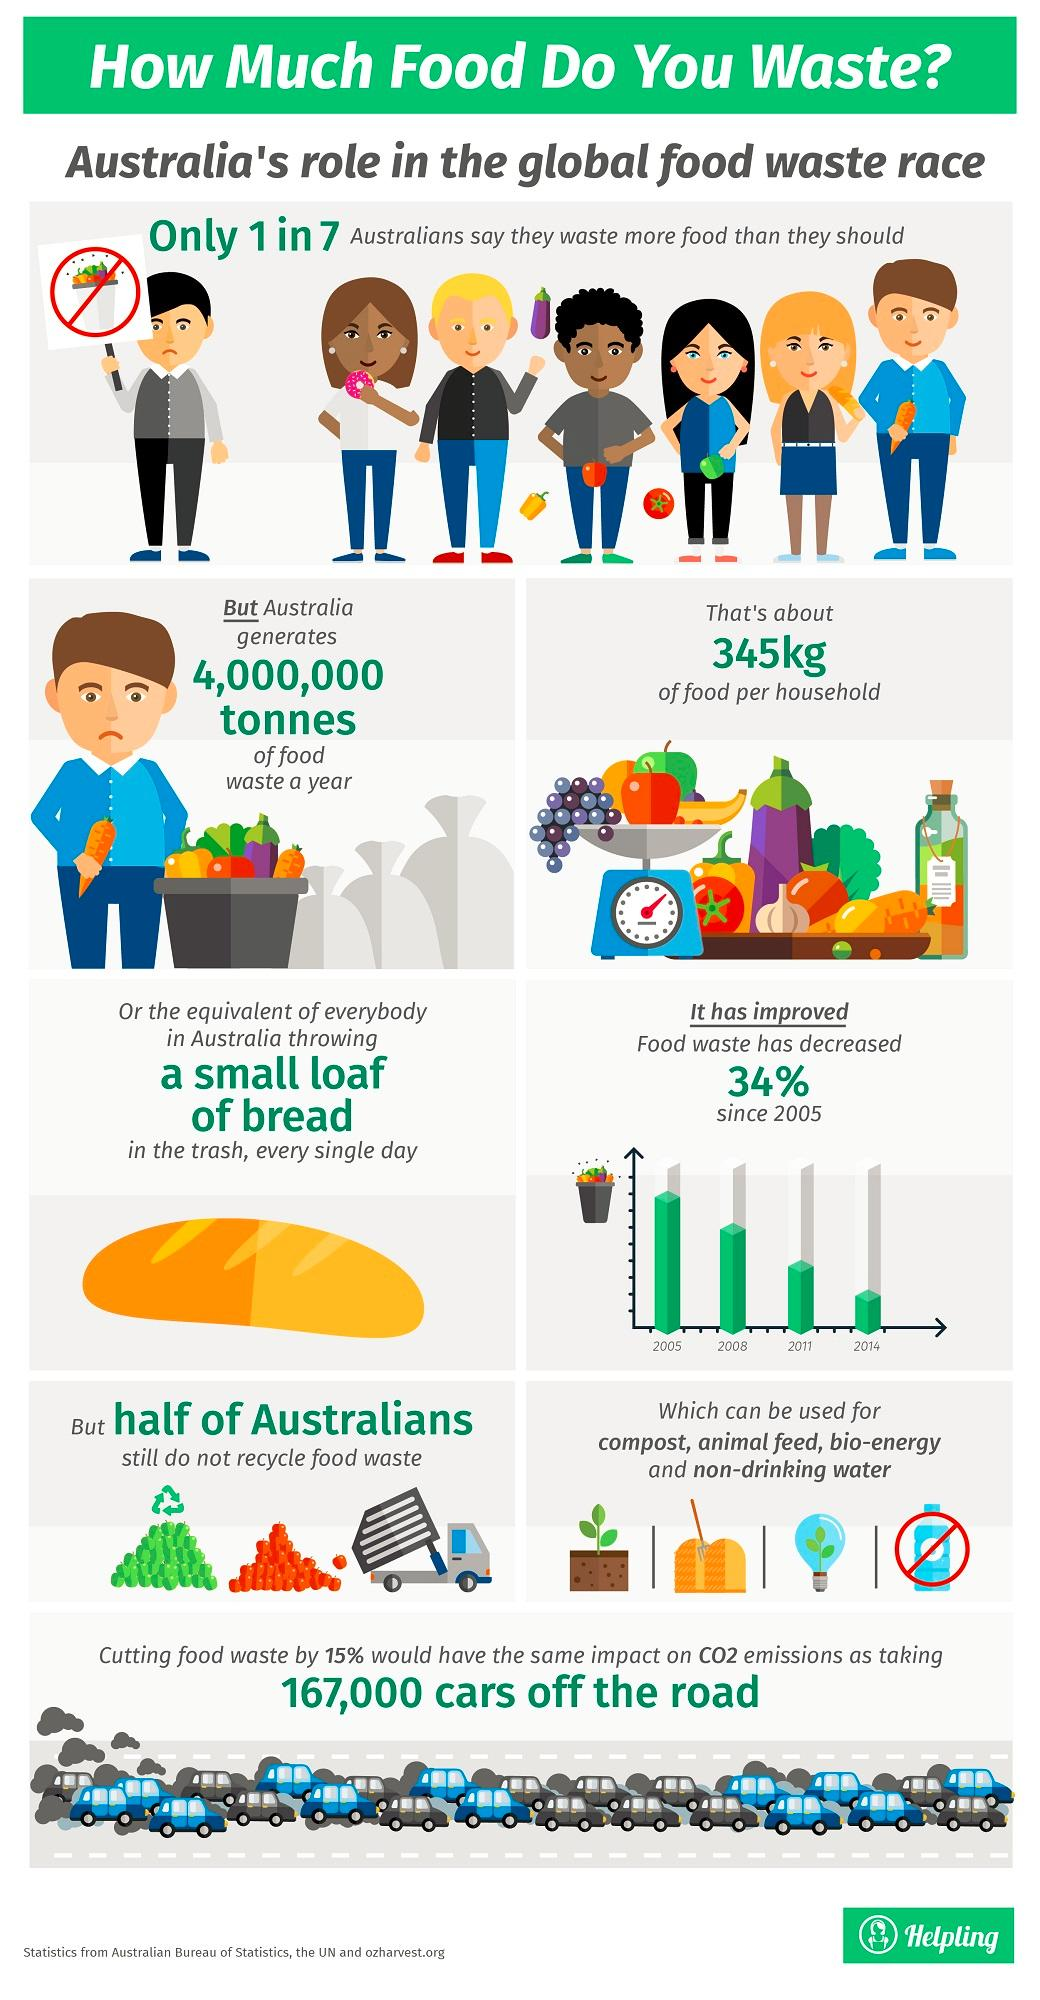Give some essential details in this illustration. Food waste compost, animal feed, bio-energy, and non-drinking water cannot be used while recycling food waste compost, animal feed, bio-energy, or non-drinking water. The lowest reduction in food waste was observed in 2014, as compared to 2005, 2008, and 2011. 